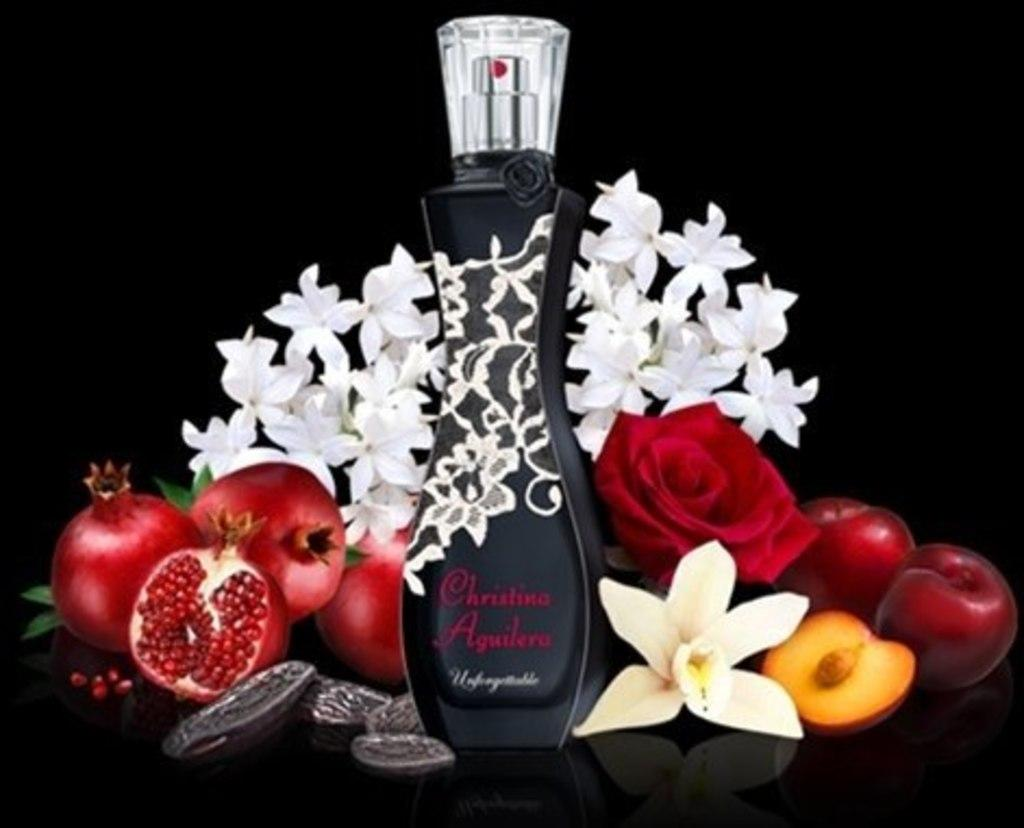<image>
Relay a brief, clear account of the picture shown. A bottle of Christina Aguilera Unforgettable surrounded by flowers and pomegranates. 